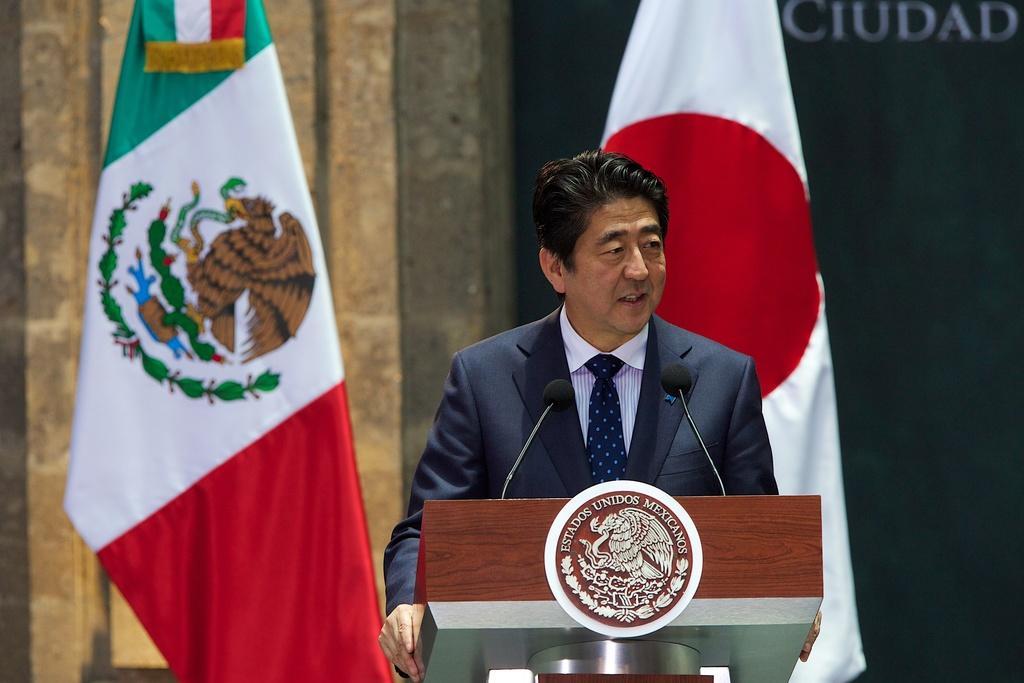In one or two sentences, can you explain what this image depicts? In this image we can see a person wearing a coat and tie is standing in front of a podium. On the podium, we can see two microphones and an emblem. In the background, we can see two flags and a wall with some text on it. 